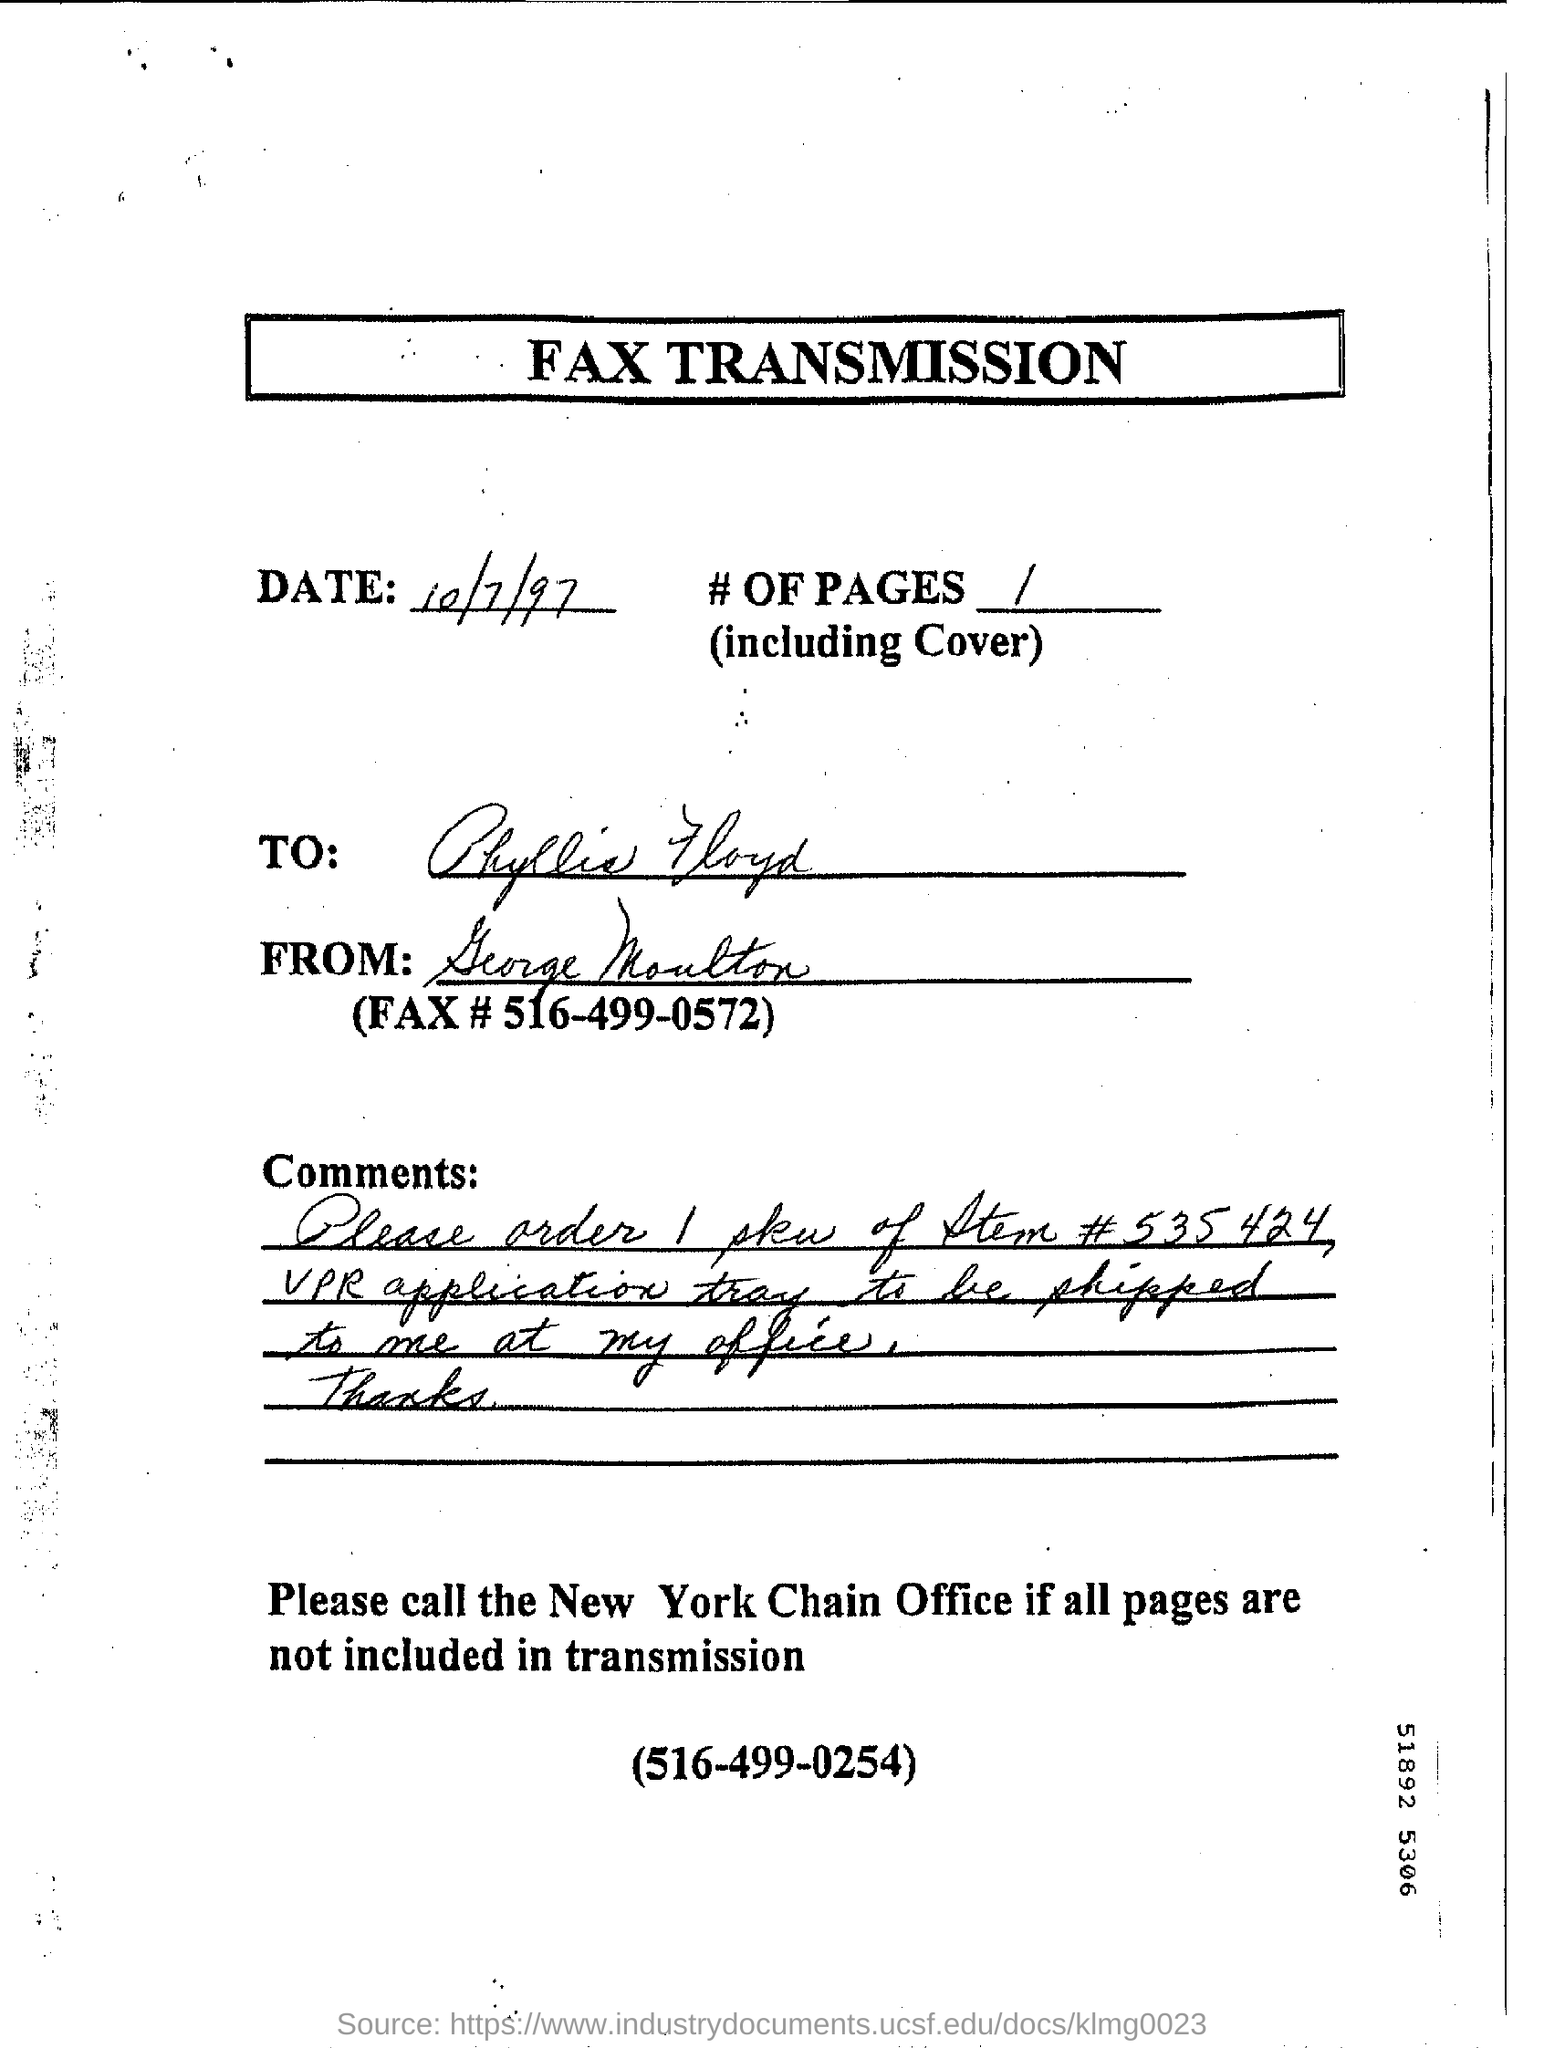Specify some key components in this picture. The heading of the document is "What is the fax transmission? The date mentioned is October 7th, 1997. 